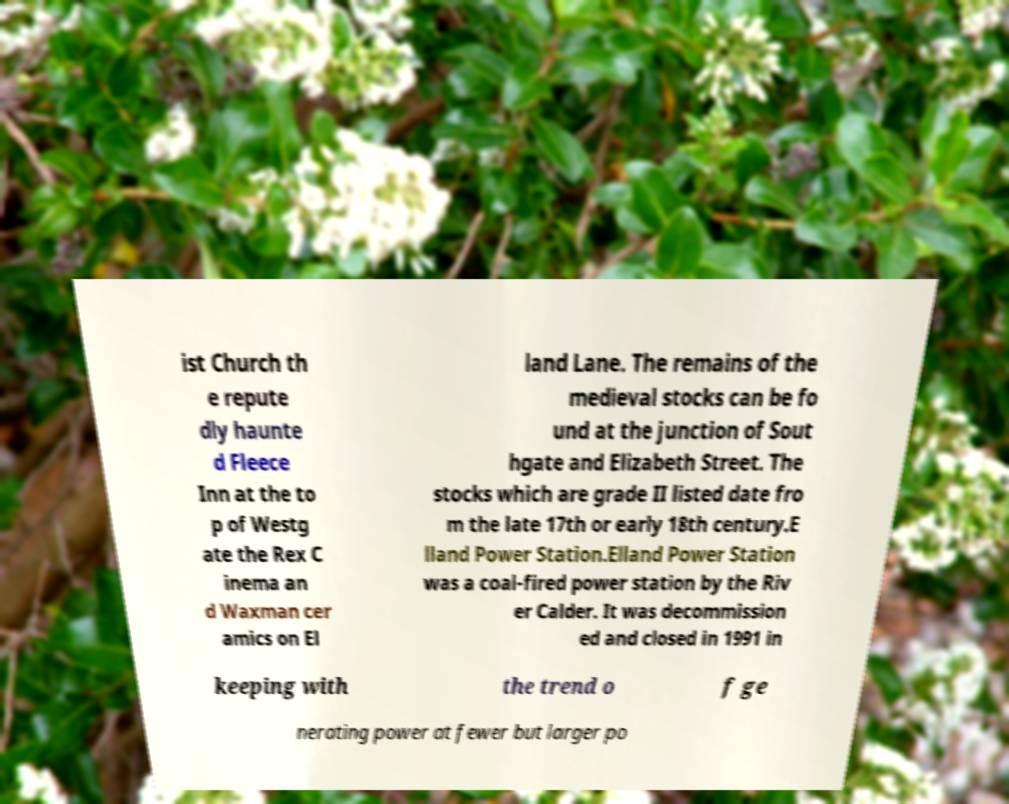For documentation purposes, I need the text within this image transcribed. Could you provide that? ist Church th e repute dly haunte d Fleece Inn at the to p of Westg ate the Rex C inema an d Waxman cer amics on El land Lane. The remains of the medieval stocks can be fo und at the junction of Sout hgate and Elizabeth Street. The stocks which are grade II listed date fro m the late 17th or early 18th century.E lland Power Station.Elland Power Station was a coal-fired power station by the Riv er Calder. It was decommission ed and closed in 1991 in keeping with the trend o f ge nerating power at fewer but larger po 